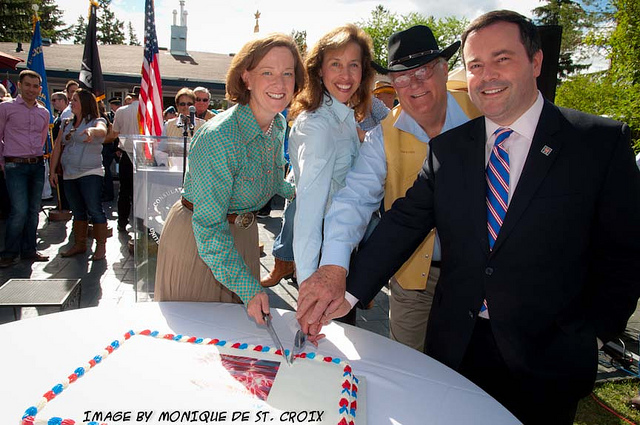Extract all visible text content from this image. CROIX MONIQUE DE ST IMAGE BY 